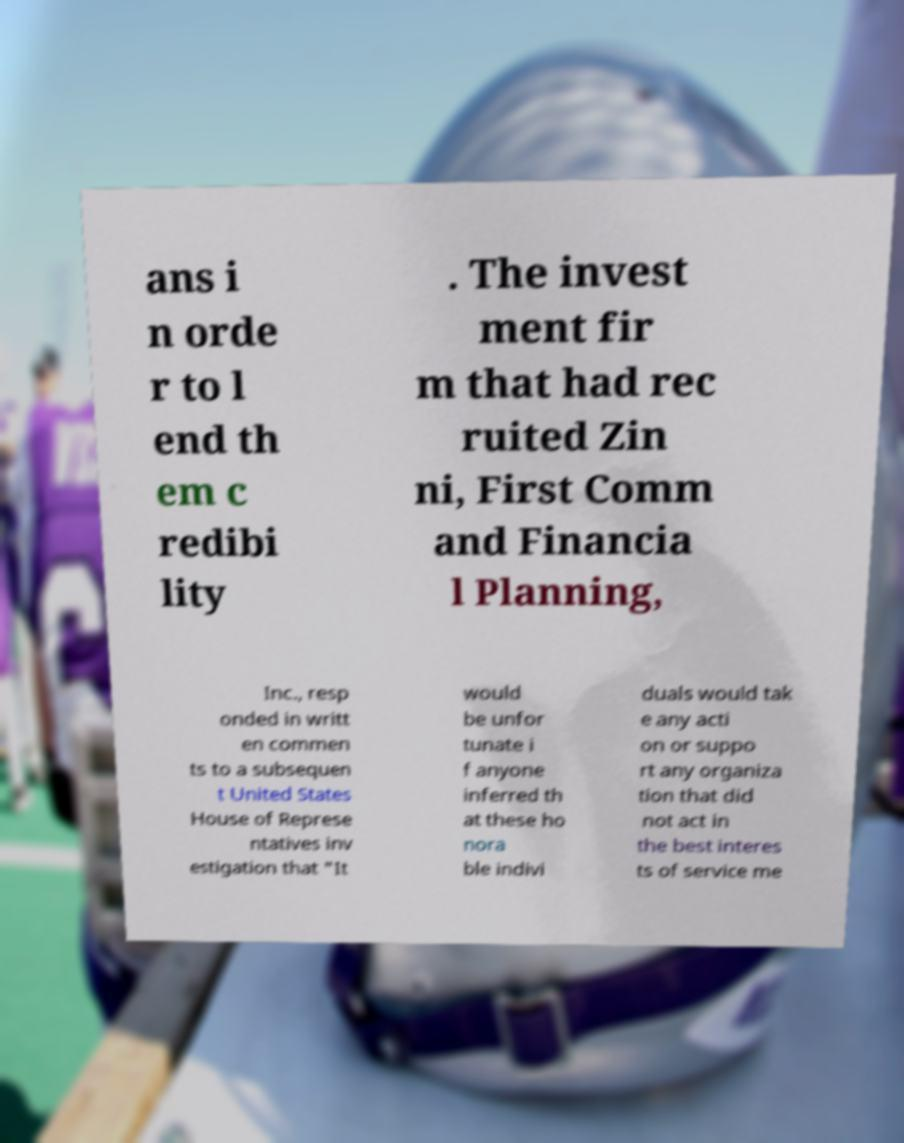Please read and relay the text visible in this image. What does it say? ans i n orde r to l end th em c redibi lity . The invest ment fir m that had rec ruited Zin ni, First Comm and Financia l Planning, Inc., resp onded in writt en commen ts to a subsequen t United States House of Represe ntatives inv estigation that "It would be unfor tunate i f anyone inferred th at these ho nora ble indivi duals would tak e any acti on or suppo rt any organiza tion that did not act in the best interes ts of service me 